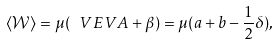Convert formula to latex. <formula><loc_0><loc_0><loc_500><loc_500>\langle \mathcal { W } \rangle = \mu ( \ V E V { A } + \beta ) = \mu ( a + b - \frac { 1 } { 2 } \delta ) ,</formula> 